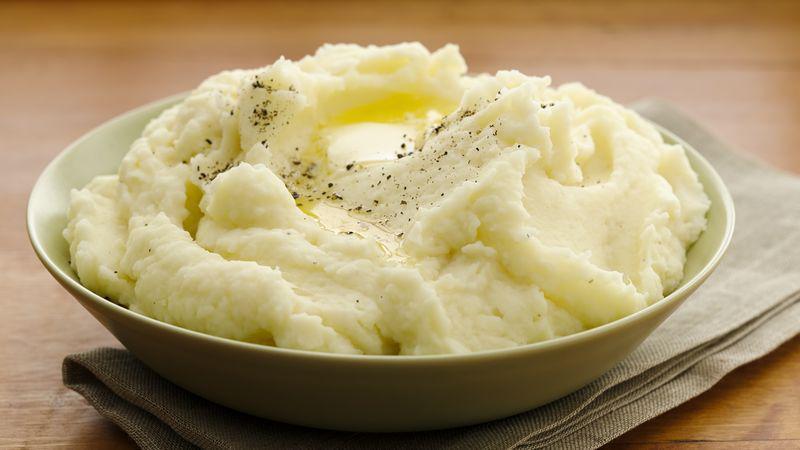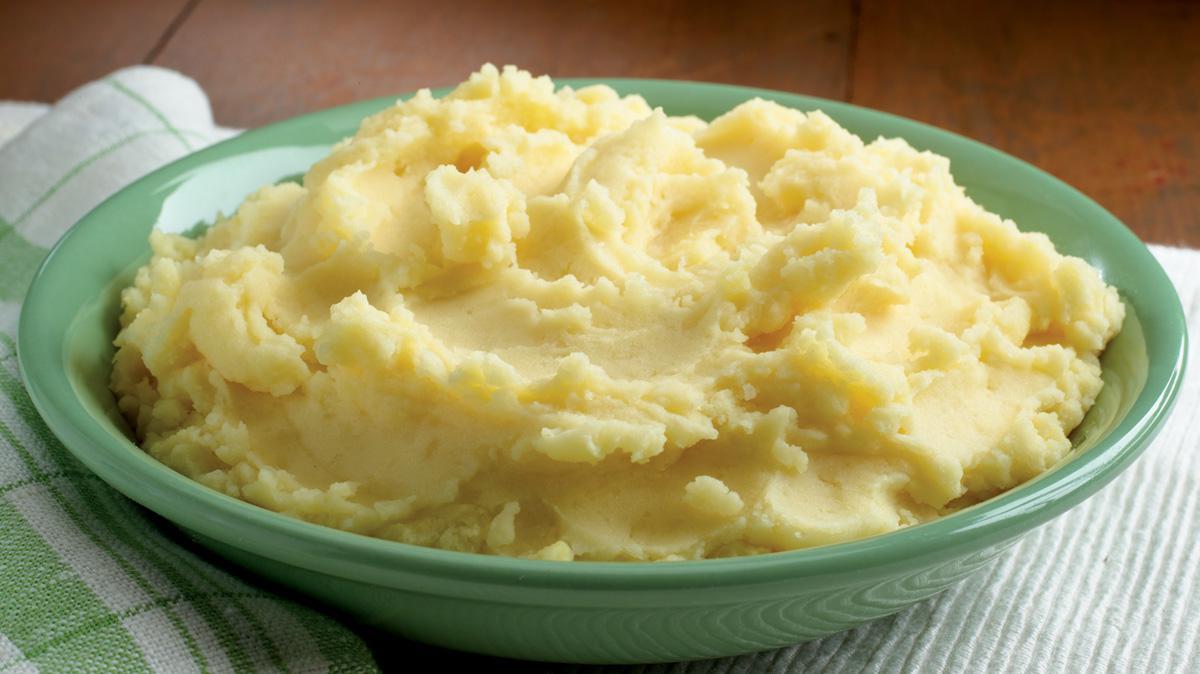The first image is the image on the left, the second image is the image on the right. Given the left and right images, does the statement "The right image contains mashed potatoes in a green bowl." hold true? Answer yes or no. Yes. 